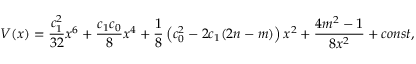Convert formula to latex. <formula><loc_0><loc_0><loc_500><loc_500>V ( x ) = \frac { c _ { 1 } ^ { 2 } } { 3 2 } x ^ { 6 } + \frac { c _ { 1 } c _ { 0 } } 8 x ^ { 4 } + \frac { 1 } { 8 } \left ( c _ { 0 } ^ { 2 } - 2 c _ { 1 } ( 2 n - m ) \right ) x ^ { 2 } + \frac { 4 m ^ { 2 } - 1 } { 8 x ^ { 2 } } + c o n s t ,</formula> 